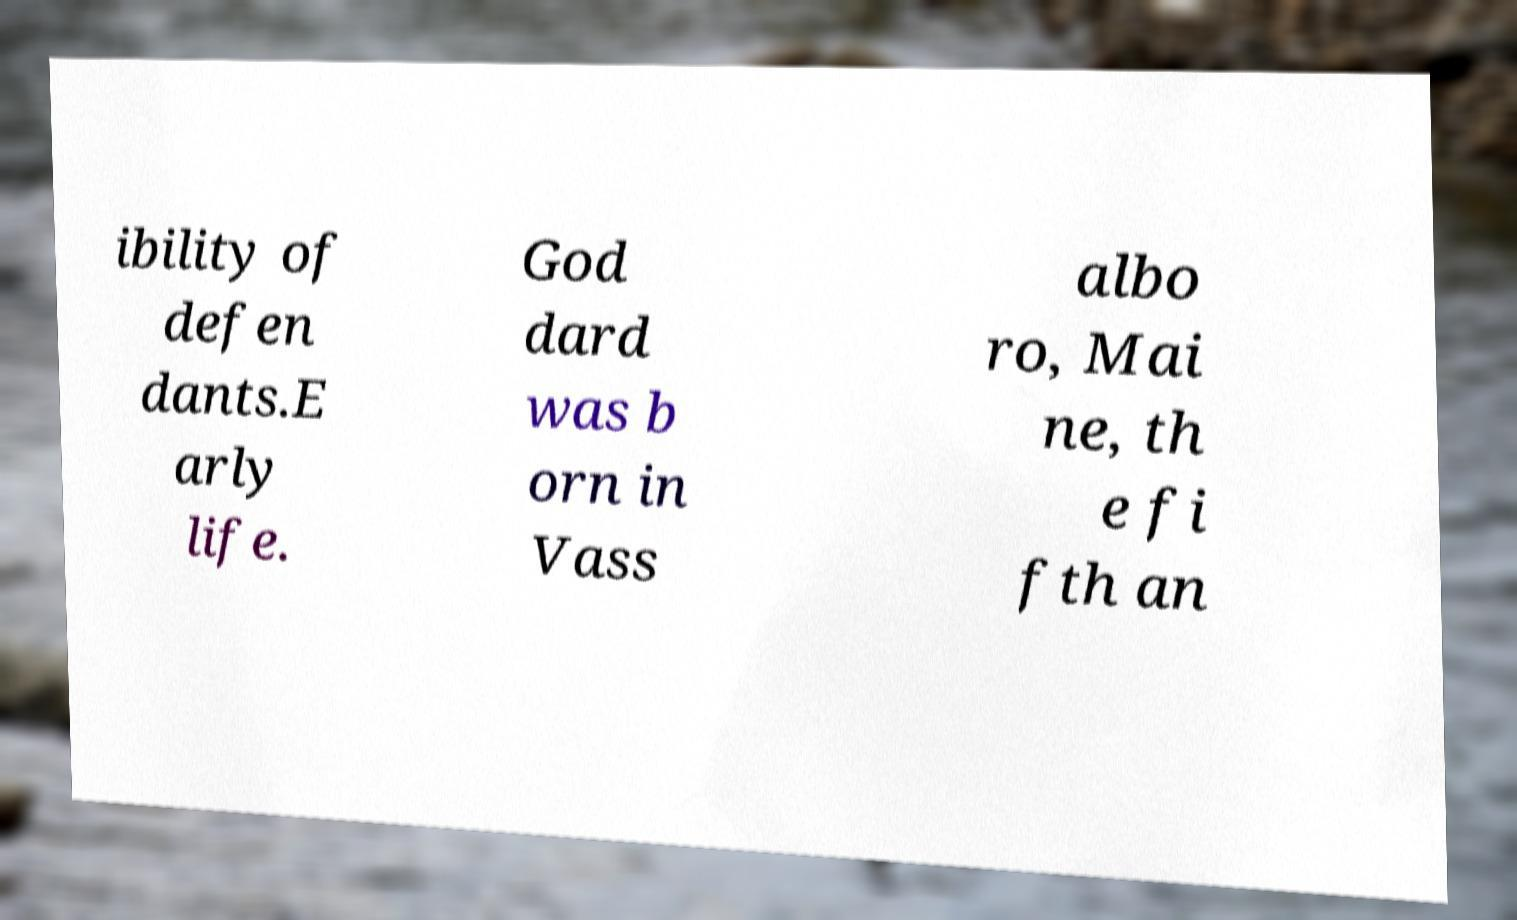Could you assist in decoding the text presented in this image and type it out clearly? ibility of defen dants.E arly life. God dard was b orn in Vass albo ro, Mai ne, th e fi fth an 